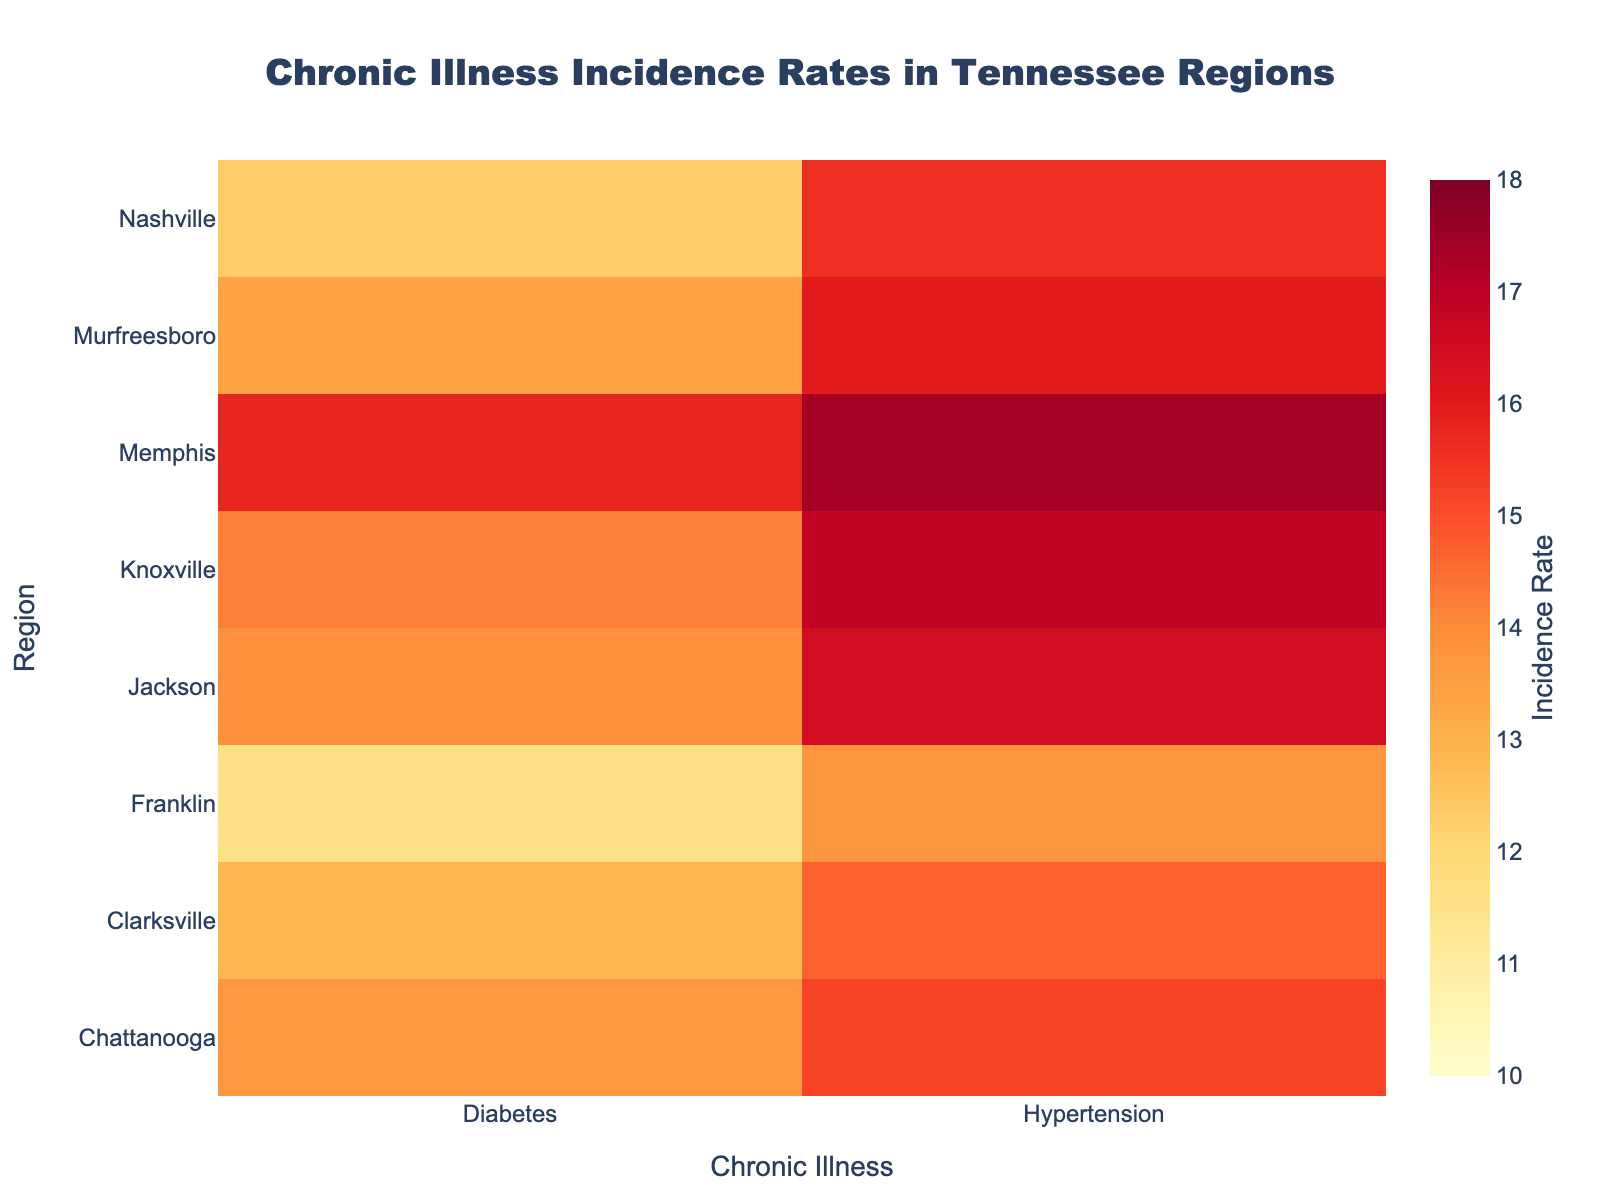What is the title of the heatmap? The title of the heatmap is displayed at the top and is a clear and prominent text indicating what the heatmap represents.
Answer: Chronic Illness Incidence Rates in Tennessee Regions Which chronic illness has the highest incidence rate in Memphis? Look for the highest value in the row corresponding to Memphis and determine the associated chronic illness.
Answer: Hypertension What is the range of incidence rates shown in the heatmap? The color bar provides a visual key indicating the minimum and maximum incidence rates represented in the heatmap. The range spans from the lowest value to the highest value shown.
Answer: 10 to 18 Which region has the lowest incidence rate of diabetes? Scan through the column for diabetes and identify the region with the smallest value.
Answer: Franklin Which chronic illness has more variability in incidence rates across different regions? Compare the range of values in each column for diabetes and hypertension to see which column has a greater difference between the maximum and minimum values.
Answer: Hypertension How many regions have a hypertension incidence rate greater than 16? Count the number of rows in the column for hypertension where the value exceeds 16.
Answer: 4 What is the average incidence rate of diabetes in all the regions? Add up all the incidence rates for diabetes across all regions and then divide by the number of regions to get the average. (12.3 + 15.8 + 14.2 + 13.7 + 12.9 + 13.4 + 11.6 + 13.9) / 8
Answer: 13.475 Which region has the smallest difference between the incidence rates of diabetes and hypertension? Calculate the absolute difference between diabetes and hypertension incidence rates for each region and find the region with the smallest difference.
Answer: Franklin What is the color representing the highest incidence rate in the heatmap? Refer to the color bar on the side of the heatmap; the color corresponding to the highest value will be in a specific shade within the color scale provided.
Answer: Dark Red Compare the incidence rate of diabetes in Nashville with that in Chattanooga. Look at the values in the diabetes column for both Nashville and Chattanooga and compare them directly. Nashville has 12.3, and Chattanooga has 13.7, thus Chattanooga is higher.
Answer: Chattanooga has a higher incidence rate 